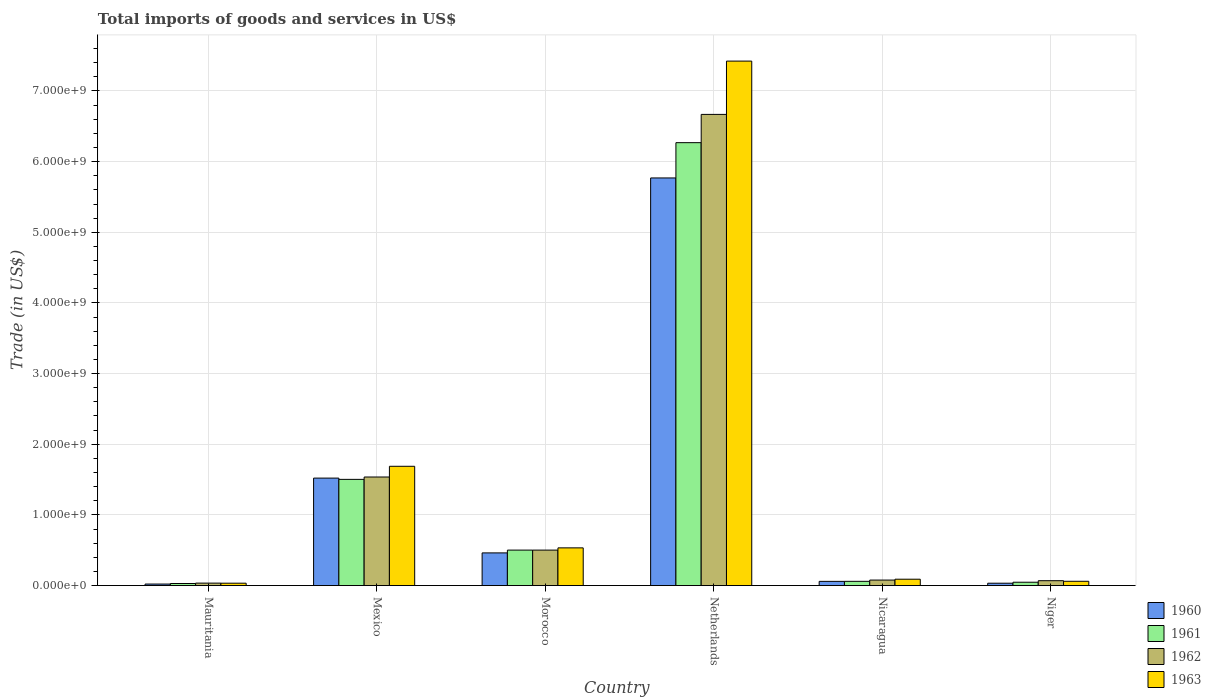Are the number of bars per tick equal to the number of legend labels?
Your response must be concise. Yes. How many bars are there on the 6th tick from the left?
Offer a terse response. 4. How many bars are there on the 2nd tick from the right?
Provide a short and direct response. 4. What is the label of the 5th group of bars from the left?
Provide a short and direct response. Nicaragua. In how many cases, is the number of bars for a given country not equal to the number of legend labels?
Make the answer very short. 0. What is the total imports of goods and services in 1962 in Morocco?
Your answer should be very brief. 5.02e+08. Across all countries, what is the maximum total imports of goods and services in 1962?
Provide a short and direct response. 6.67e+09. Across all countries, what is the minimum total imports of goods and services in 1960?
Offer a terse response. 2.13e+07. In which country was the total imports of goods and services in 1961 minimum?
Your answer should be very brief. Mauritania. What is the total total imports of goods and services in 1961 in the graph?
Make the answer very short. 8.41e+09. What is the difference between the total imports of goods and services in 1961 in Mexico and that in Netherlands?
Keep it short and to the point. -4.77e+09. What is the difference between the total imports of goods and services in 1961 in Mauritania and the total imports of goods and services in 1962 in Mexico?
Offer a very short reply. -1.51e+09. What is the average total imports of goods and services in 1960 per country?
Ensure brevity in your answer.  1.31e+09. What is the difference between the total imports of goods and services of/in 1961 and total imports of goods and services of/in 1960 in Morocco?
Your response must be concise. 3.95e+07. What is the ratio of the total imports of goods and services in 1963 in Morocco to that in Netherlands?
Give a very brief answer. 0.07. What is the difference between the highest and the second highest total imports of goods and services in 1960?
Offer a very short reply. 4.25e+09. What is the difference between the highest and the lowest total imports of goods and services in 1960?
Your answer should be compact. 5.75e+09. Is the sum of the total imports of goods and services in 1963 in Mauritania and Mexico greater than the maximum total imports of goods and services in 1961 across all countries?
Provide a succinct answer. No. Is it the case that in every country, the sum of the total imports of goods and services in 1963 and total imports of goods and services in 1961 is greater than the sum of total imports of goods and services in 1960 and total imports of goods and services in 1962?
Keep it short and to the point. No. How many countries are there in the graph?
Make the answer very short. 6. What is the title of the graph?
Offer a terse response. Total imports of goods and services in US$. Does "2003" appear as one of the legend labels in the graph?
Ensure brevity in your answer.  No. What is the label or title of the Y-axis?
Offer a terse response. Trade (in US$). What is the Trade (in US$) of 1960 in Mauritania?
Offer a terse response. 2.13e+07. What is the Trade (in US$) in 1961 in Mauritania?
Your answer should be very brief. 2.91e+07. What is the Trade (in US$) in 1962 in Mauritania?
Your answer should be very brief. 3.46e+07. What is the Trade (in US$) in 1963 in Mauritania?
Give a very brief answer. 3.36e+07. What is the Trade (in US$) in 1960 in Mexico?
Your response must be concise. 1.52e+09. What is the Trade (in US$) in 1961 in Mexico?
Ensure brevity in your answer.  1.50e+09. What is the Trade (in US$) in 1962 in Mexico?
Your answer should be compact. 1.54e+09. What is the Trade (in US$) in 1963 in Mexico?
Give a very brief answer. 1.69e+09. What is the Trade (in US$) of 1960 in Morocco?
Offer a very short reply. 4.62e+08. What is the Trade (in US$) of 1961 in Morocco?
Make the answer very short. 5.02e+08. What is the Trade (in US$) in 1962 in Morocco?
Your answer should be compact. 5.02e+08. What is the Trade (in US$) of 1963 in Morocco?
Make the answer very short. 5.34e+08. What is the Trade (in US$) of 1960 in Netherlands?
Provide a succinct answer. 5.77e+09. What is the Trade (in US$) in 1961 in Netherlands?
Your answer should be very brief. 6.27e+09. What is the Trade (in US$) in 1962 in Netherlands?
Offer a terse response. 6.67e+09. What is the Trade (in US$) in 1963 in Netherlands?
Provide a succinct answer. 7.42e+09. What is the Trade (in US$) of 1960 in Nicaragua?
Keep it short and to the point. 5.95e+07. What is the Trade (in US$) in 1961 in Nicaragua?
Provide a succinct answer. 5.99e+07. What is the Trade (in US$) in 1962 in Nicaragua?
Make the answer very short. 7.78e+07. What is the Trade (in US$) in 1963 in Nicaragua?
Ensure brevity in your answer.  8.99e+07. What is the Trade (in US$) in 1960 in Niger?
Provide a succinct answer. 3.33e+07. What is the Trade (in US$) in 1961 in Niger?
Your answer should be very brief. 4.71e+07. What is the Trade (in US$) in 1962 in Niger?
Offer a very short reply. 6.88e+07. What is the Trade (in US$) of 1963 in Niger?
Your response must be concise. 6.05e+07. Across all countries, what is the maximum Trade (in US$) of 1960?
Your answer should be compact. 5.77e+09. Across all countries, what is the maximum Trade (in US$) of 1961?
Ensure brevity in your answer.  6.27e+09. Across all countries, what is the maximum Trade (in US$) in 1962?
Provide a succinct answer. 6.67e+09. Across all countries, what is the maximum Trade (in US$) of 1963?
Offer a very short reply. 7.42e+09. Across all countries, what is the minimum Trade (in US$) in 1960?
Provide a succinct answer. 2.13e+07. Across all countries, what is the minimum Trade (in US$) in 1961?
Keep it short and to the point. 2.91e+07. Across all countries, what is the minimum Trade (in US$) in 1962?
Keep it short and to the point. 3.46e+07. Across all countries, what is the minimum Trade (in US$) of 1963?
Offer a very short reply. 3.36e+07. What is the total Trade (in US$) of 1960 in the graph?
Ensure brevity in your answer.  7.87e+09. What is the total Trade (in US$) of 1961 in the graph?
Your answer should be compact. 8.41e+09. What is the total Trade (in US$) in 1962 in the graph?
Your response must be concise. 8.89e+09. What is the total Trade (in US$) in 1963 in the graph?
Provide a succinct answer. 9.83e+09. What is the difference between the Trade (in US$) of 1960 in Mauritania and that in Mexico?
Make the answer very short. -1.50e+09. What is the difference between the Trade (in US$) in 1961 in Mauritania and that in Mexico?
Give a very brief answer. -1.47e+09. What is the difference between the Trade (in US$) of 1962 in Mauritania and that in Mexico?
Give a very brief answer. -1.50e+09. What is the difference between the Trade (in US$) in 1963 in Mauritania and that in Mexico?
Keep it short and to the point. -1.65e+09. What is the difference between the Trade (in US$) of 1960 in Mauritania and that in Morocco?
Make the answer very short. -4.41e+08. What is the difference between the Trade (in US$) in 1961 in Mauritania and that in Morocco?
Your answer should be very brief. -4.73e+08. What is the difference between the Trade (in US$) of 1962 in Mauritania and that in Morocco?
Ensure brevity in your answer.  -4.67e+08. What is the difference between the Trade (in US$) of 1963 in Mauritania and that in Morocco?
Provide a short and direct response. -5.00e+08. What is the difference between the Trade (in US$) of 1960 in Mauritania and that in Netherlands?
Offer a terse response. -5.75e+09. What is the difference between the Trade (in US$) in 1961 in Mauritania and that in Netherlands?
Provide a short and direct response. -6.24e+09. What is the difference between the Trade (in US$) of 1962 in Mauritania and that in Netherlands?
Provide a succinct answer. -6.63e+09. What is the difference between the Trade (in US$) in 1963 in Mauritania and that in Netherlands?
Offer a very short reply. -7.39e+09. What is the difference between the Trade (in US$) in 1960 in Mauritania and that in Nicaragua?
Give a very brief answer. -3.82e+07. What is the difference between the Trade (in US$) in 1961 in Mauritania and that in Nicaragua?
Provide a short and direct response. -3.08e+07. What is the difference between the Trade (in US$) of 1962 in Mauritania and that in Nicaragua?
Your answer should be compact. -4.33e+07. What is the difference between the Trade (in US$) in 1963 in Mauritania and that in Nicaragua?
Your answer should be very brief. -5.63e+07. What is the difference between the Trade (in US$) of 1960 in Mauritania and that in Niger?
Offer a very short reply. -1.20e+07. What is the difference between the Trade (in US$) in 1961 in Mauritania and that in Niger?
Your answer should be very brief. -1.80e+07. What is the difference between the Trade (in US$) in 1962 in Mauritania and that in Niger?
Give a very brief answer. -3.43e+07. What is the difference between the Trade (in US$) in 1963 in Mauritania and that in Niger?
Keep it short and to the point. -2.69e+07. What is the difference between the Trade (in US$) in 1960 in Mexico and that in Morocco?
Make the answer very short. 1.06e+09. What is the difference between the Trade (in US$) of 1961 in Mexico and that in Morocco?
Offer a terse response. 1.00e+09. What is the difference between the Trade (in US$) in 1962 in Mexico and that in Morocco?
Ensure brevity in your answer.  1.03e+09. What is the difference between the Trade (in US$) of 1963 in Mexico and that in Morocco?
Make the answer very short. 1.15e+09. What is the difference between the Trade (in US$) in 1960 in Mexico and that in Netherlands?
Ensure brevity in your answer.  -4.25e+09. What is the difference between the Trade (in US$) of 1961 in Mexico and that in Netherlands?
Keep it short and to the point. -4.77e+09. What is the difference between the Trade (in US$) in 1962 in Mexico and that in Netherlands?
Your answer should be compact. -5.13e+09. What is the difference between the Trade (in US$) of 1963 in Mexico and that in Netherlands?
Give a very brief answer. -5.74e+09. What is the difference between the Trade (in US$) in 1960 in Mexico and that in Nicaragua?
Keep it short and to the point. 1.46e+09. What is the difference between the Trade (in US$) of 1961 in Mexico and that in Nicaragua?
Give a very brief answer. 1.44e+09. What is the difference between the Trade (in US$) of 1962 in Mexico and that in Nicaragua?
Offer a very short reply. 1.46e+09. What is the difference between the Trade (in US$) of 1963 in Mexico and that in Nicaragua?
Your response must be concise. 1.60e+09. What is the difference between the Trade (in US$) in 1960 in Mexico and that in Niger?
Ensure brevity in your answer.  1.49e+09. What is the difference between the Trade (in US$) in 1961 in Mexico and that in Niger?
Your response must be concise. 1.46e+09. What is the difference between the Trade (in US$) in 1962 in Mexico and that in Niger?
Offer a very short reply. 1.47e+09. What is the difference between the Trade (in US$) of 1963 in Mexico and that in Niger?
Ensure brevity in your answer.  1.63e+09. What is the difference between the Trade (in US$) of 1960 in Morocco and that in Netherlands?
Offer a very short reply. -5.31e+09. What is the difference between the Trade (in US$) in 1961 in Morocco and that in Netherlands?
Provide a short and direct response. -5.77e+09. What is the difference between the Trade (in US$) of 1962 in Morocco and that in Netherlands?
Your answer should be very brief. -6.17e+09. What is the difference between the Trade (in US$) of 1963 in Morocco and that in Netherlands?
Offer a very short reply. -6.89e+09. What is the difference between the Trade (in US$) of 1960 in Morocco and that in Nicaragua?
Ensure brevity in your answer.  4.03e+08. What is the difference between the Trade (in US$) of 1961 in Morocco and that in Nicaragua?
Your answer should be very brief. 4.42e+08. What is the difference between the Trade (in US$) of 1962 in Morocco and that in Nicaragua?
Provide a succinct answer. 4.24e+08. What is the difference between the Trade (in US$) of 1963 in Morocco and that in Nicaragua?
Offer a very short reply. 4.44e+08. What is the difference between the Trade (in US$) in 1960 in Morocco and that in Niger?
Your response must be concise. 4.29e+08. What is the difference between the Trade (in US$) of 1961 in Morocco and that in Niger?
Offer a very short reply. 4.55e+08. What is the difference between the Trade (in US$) of 1962 in Morocco and that in Niger?
Provide a succinct answer. 4.33e+08. What is the difference between the Trade (in US$) in 1963 in Morocco and that in Niger?
Give a very brief answer. 4.73e+08. What is the difference between the Trade (in US$) of 1960 in Netherlands and that in Nicaragua?
Offer a very short reply. 5.71e+09. What is the difference between the Trade (in US$) in 1961 in Netherlands and that in Nicaragua?
Offer a very short reply. 6.21e+09. What is the difference between the Trade (in US$) of 1962 in Netherlands and that in Nicaragua?
Give a very brief answer. 6.59e+09. What is the difference between the Trade (in US$) in 1963 in Netherlands and that in Nicaragua?
Provide a short and direct response. 7.33e+09. What is the difference between the Trade (in US$) of 1960 in Netherlands and that in Niger?
Offer a very short reply. 5.74e+09. What is the difference between the Trade (in US$) of 1961 in Netherlands and that in Niger?
Offer a terse response. 6.22e+09. What is the difference between the Trade (in US$) of 1962 in Netherlands and that in Niger?
Keep it short and to the point. 6.60e+09. What is the difference between the Trade (in US$) of 1963 in Netherlands and that in Niger?
Your answer should be very brief. 7.36e+09. What is the difference between the Trade (in US$) of 1960 in Nicaragua and that in Niger?
Offer a very short reply. 2.62e+07. What is the difference between the Trade (in US$) in 1961 in Nicaragua and that in Niger?
Give a very brief answer. 1.28e+07. What is the difference between the Trade (in US$) of 1962 in Nicaragua and that in Niger?
Provide a short and direct response. 8.98e+06. What is the difference between the Trade (in US$) of 1963 in Nicaragua and that in Niger?
Provide a short and direct response. 2.94e+07. What is the difference between the Trade (in US$) of 1960 in Mauritania and the Trade (in US$) of 1961 in Mexico?
Provide a succinct answer. -1.48e+09. What is the difference between the Trade (in US$) of 1960 in Mauritania and the Trade (in US$) of 1962 in Mexico?
Your response must be concise. -1.52e+09. What is the difference between the Trade (in US$) of 1960 in Mauritania and the Trade (in US$) of 1963 in Mexico?
Provide a succinct answer. -1.67e+09. What is the difference between the Trade (in US$) in 1961 in Mauritania and the Trade (in US$) in 1962 in Mexico?
Your answer should be very brief. -1.51e+09. What is the difference between the Trade (in US$) of 1961 in Mauritania and the Trade (in US$) of 1963 in Mexico?
Provide a succinct answer. -1.66e+09. What is the difference between the Trade (in US$) of 1962 in Mauritania and the Trade (in US$) of 1963 in Mexico?
Offer a very short reply. -1.65e+09. What is the difference between the Trade (in US$) of 1960 in Mauritania and the Trade (in US$) of 1961 in Morocco?
Keep it short and to the point. -4.81e+08. What is the difference between the Trade (in US$) in 1960 in Mauritania and the Trade (in US$) in 1962 in Morocco?
Keep it short and to the point. -4.81e+08. What is the difference between the Trade (in US$) of 1960 in Mauritania and the Trade (in US$) of 1963 in Morocco?
Your answer should be compact. -5.12e+08. What is the difference between the Trade (in US$) of 1961 in Mauritania and the Trade (in US$) of 1962 in Morocco?
Your answer should be very brief. -4.73e+08. What is the difference between the Trade (in US$) in 1961 in Mauritania and the Trade (in US$) in 1963 in Morocco?
Provide a succinct answer. -5.04e+08. What is the difference between the Trade (in US$) in 1962 in Mauritania and the Trade (in US$) in 1963 in Morocco?
Make the answer very short. -4.99e+08. What is the difference between the Trade (in US$) in 1960 in Mauritania and the Trade (in US$) in 1961 in Netherlands?
Keep it short and to the point. -6.25e+09. What is the difference between the Trade (in US$) in 1960 in Mauritania and the Trade (in US$) in 1962 in Netherlands?
Provide a succinct answer. -6.65e+09. What is the difference between the Trade (in US$) in 1960 in Mauritania and the Trade (in US$) in 1963 in Netherlands?
Offer a terse response. -7.40e+09. What is the difference between the Trade (in US$) in 1961 in Mauritania and the Trade (in US$) in 1962 in Netherlands?
Offer a terse response. -6.64e+09. What is the difference between the Trade (in US$) of 1961 in Mauritania and the Trade (in US$) of 1963 in Netherlands?
Provide a short and direct response. -7.39e+09. What is the difference between the Trade (in US$) of 1962 in Mauritania and the Trade (in US$) of 1963 in Netherlands?
Offer a very short reply. -7.39e+09. What is the difference between the Trade (in US$) in 1960 in Mauritania and the Trade (in US$) in 1961 in Nicaragua?
Offer a terse response. -3.87e+07. What is the difference between the Trade (in US$) of 1960 in Mauritania and the Trade (in US$) of 1962 in Nicaragua?
Your answer should be very brief. -5.65e+07. What is the difference between the Trade (in US$) in 1960 in Mauritania and the Trade (in US$) in 1963 in Nicaragua?
Ensure brevity in your answer.  -6.86e+07. What is the difference between the Trade (in US$) in 1961 in Mauritania and the Trade (in US$) in 1962 in Nicaragua?
Offer a very short reply. -4.87e+07. What is the difference between the Trade (in US$) in 1961 in Mauritania and the Trade (in US$) in 1963 in Nicaragua?
Provide a succinct answer. -6.08e+07. What is the difference between the Trade (in US$) in 1962 in Mauritania and the Trade (in US$) in 1963 in Nicaragua?
Offer a terse response. -5.54e+07. What is the difference between the Trade (in US$) of 1960 in Mauritania and the Trade (in US$) of 1961 in Niger?
Provide a short and direct response. -2.59e+07. What is the difference between the Trade (in US$) of 1960 in Mauritania and the Trade (in US$) of 1962 in Niger?
Offer a very short reply. -4.76e+07. What is the difference between the Trade (in US$) of 1960 in Mauritania and the Trade (in US$) of 1963 in Niger?
Your response must be concise. -3.92e+07. What is the difference between the Trade (in US$) in 1961 in Mauritania and the Trade (in US$) in 1962 in Niger?
Provide a succinct answer. -3.97e+07. What is the difference between the Trade (in US$) of 1961 in Mauritania and the Trade (in US$) of 1963 in Niger?
Your answer should be very brief. -3.14e+07. What is the difference between the Trade (in US$) of 1962 in Mauritania and the Trade (in US$) of 1963 in Niger?
Offer a terse response. -2.60e+07. What is the difference between the Trade (in US$) of 1960 in Mexico and the Trade (in US$) of 1961 in Morocco?
Offer a terse response. 1.02e+09. What is the difference between the Trade (in US$) of 1960 in Mexico and the Trade (in US$) of 1962 in Morocco?
Provide a succinct answer. 1.02e+09. What is the difference between the Trade (in US$) in 1960 in Mexico and the Trade (in US$) in 1963 in Morocco?
Ensure brevity in your answer.  9.87e+08. What is the difference between the Trade (in US$) in 1961 in Mexico and the Trade (in US$) in 1962 in Morocco?
Your answer should be compact. 1.00e+09. What is the difference between the Trade (in US$) of 1961 in Mexico and the Trade (in US$) of 1963 in Morocco?
Ensure brevity in your answer.  9.70e+08. What is the difference between the Trade (in US$) of 1962 in Mexico and the Trade (in US$) of 1963 in Morocco?
Offer a very short reply. 1.00e+09. What is the difference between the Trade (in US$) of 1960 in Mexico and the Trade (in US$) of 1961 in Netherlands?
Provide a succinct answer. -4.75e+09. What is the difference between the Trade (in US$) in 1960 in Mexico and the Trade (in US$) in 1962 in Netherlands?
Ensure brevity in your answer.  -5.15e+09. What is the difference between the Trade (in US$) of 1960 in Mexico and the Trade (in US$) of 1963 in Netherlands?
Your answer should be very brief. -5.90e+09. What is the difference between the Trade (in US$) of 1961 in Mexico and the Trade (in US$) of 1962 in Netherlands?
Keep it short and to the point. -5.17e+09. What is the difference between the Trade (in US$) of 1961 in Mexico and the Trade (in US$) of 1963 in Netherlands?
Make the answer very short. -5.92e+09. What is the difference between the Trade (in US$) of 1962 in Mexico and the Trade (in US$) of 1963 in Netherlands?
Ensure brevity in your answer.  -5.89e+09. What is the difference between the Trade (in US$) of 1960 in Mexico and the Trade (in US$) of 1961 in Nicaragua?
Offer a terse response. 1.46e+09. What is the difference between the Trade (in US$) of 1960 in Mexico and the Trade (in US$) of 1962 in Nicaragua?
Keep it short and to the point. 1.44e+09. What is the difference between the Trade (in US$) of 1960 in Mexico and the Trade (in US$) of 1963 in Nicaragua?
Offer a terse response. 1.43e+09. What is the difference between the Trade (in US$) of 1961 in Mexico and the Trade (in US$) of 1962 in Nicaragua?
Your answer should be compact. 1.43e+09. What is the difference between the Trade (in US$) of 1961 in Mexico and the Trade (in US$) of 1963 in Nicaragua?
Your answer should be compact. 1.41e+09. What is the difference between the Trade (in US$) in 1962 in Mexico and the Trade (in US$) in 1963 in Nicaragua?
Offer a terse response. 1.45e+09. What is the difference between the Trade (in US$) of 1960 in Mexico and the Trade (in US$) of 1961 in Niger?
Your answer should be very brief. 1.47e+09. What is the difference between the Trade (in US$) of 1960 in Mexico and the Trade (in US$) of 1962 in Niger?
Make the answer very short. 1.45e+09. What is the difference between the Trade (in US$) of 1960 in Mexico and the Trade (in US$) of 1963 in Niger?
Give a very brief answer. 1.46e+09. What is the difference between the Trade (in US$) in 1961 in Mexico and the Trade (in US$) in 1962 in Niger?
Your answer should be compact. 1.43e+09. What is the difference between the Trade (in US$) of 1961 in Mexico and the Trade (in US$) of 1963 in Niger?
Offer a terse response. 1.44e+09. What is the difference between the Trade (in US$) of 1962 in Mexico and the Trade (in US$) of 1963 in Niger?
Provide a succinct answer. 1.48e+09. What is the difference between the Trade (in US$) in 1960 in Morocco and the Trade (in US$) in 1961 in Netherlands?
Your answer should be very brief. -5.81e+09. What is the difference between the Trade (in US$) in 1960 in Morocco and the Trade (in US$) in 1962 in Netherlands?
Keep it short and to the point. -6.21e+09. What is the difference between the Trade (in US$) in 1960 in Morocco and the Trade (in US$) in 1963 in Netherlands?
Give a very brief answer. -6.96e+09. What is the difference between the Trade (in US$) of 1961 in Morocco and the Trade (in US$) of 1962 in Netherlands?
Offer a terse response. -6.17e+09. What is the difference between the Trade (in US$) in 1961 in Morocco and the Trade (in US$) in 1963 in Netherlands?
Provide a short and direct response. -6.92e+09. What is the difference between the Trade (in US$) of 1962 in Morocco and the Trade (in US$) of 1963 in Netherlands?
Your answer should be compact. -6.92e+09. What is the difference between the Trade (in US$) in 1960 in Morocco and the Trade (in US$) in 1961 in Nicaragua?
Offer a terse response. 4.02e+08. What is the difference between the Trade (in US$) of 1960 in Morocco and the Trade (in US$) of 1962 in Nicaragua?
Keep it short and to the point. 3.85e+08. What is the difference between the Trade (in US$) in 1960 in Morocco and the Trade (in US$) in 1963 in Nicaragua?
Give a very brief answer. 3.72e+08. What is the difference between the Trade (in US$) of 1961 in Morocco and the Trade (in US$) of 1962 in Nicaragua?
Provide a short and direct response. 4.24e+08. What is the difference between the Trade (in US$) of 1961 in Morocco and the Trade (in US$) of 1963 in Nicaragua?
Give a very brief answer. 4.12e+08. What is the difference between the Trade (in US$) in 1962 in Morocco and the Trade (in US$) in 1963 in Nicaragua?
Give a very brief answer. 4.12e+08. What is the difference between the Trade (in US$) in 1960 in Morocco and the Trade (in US$) in 1961 in Niger?
Provide a short and direct response. 4.15e+08. What is the difference between the Trade (in US$) in 1960 in Morocco and the Trade (in US$) in 1962 in Niger?
Your answer should be compact. 3.94e+08. What is the difference between the Trade (in US$) of 1960 in Morocco and the Trade (in US$) of 1963 in Niger?
Your response must be concise. 4.02e+08. What is the difference between the Trade (in US$) of 1961 in Morocco and the Trade (in US$) of 1962 in Niger?
Provide a succinct answer. 4.33e+08. What is the difference between the Trade (in US$) in 1961 in Morocco and the Trade (in US$) in 1963 in Niger?
Provide a short and direct response. 4.41e+08. What is the difference between the Trade (in US$) of 1962 in Morocco and the Trade (in US$) of 1963 in Niger?
Your answer should be compact. 4.41e+08. What is the difference between the Trade (in US$) in 1960 in Netherlands and the Trade (in US$) in 1961 in Nicaragua?
Your answer should be compact. 5.71e+09. What is the difference between the Trade (in US$) in 1960 in Netherlands and the Trade (in US$) in 1962 in Nicaragua?
Keep it short and to the point. 5.69e+09. What is the difference between the Trade (in US$) of 1960 in Netherlands and the Trade (in US$) of 1963 in Nicaragua?
Provide a succinct answer. 5.68e+09. What is the difference between the Trade (in US$) of 1961 in Netherlands and the Trade (in US$) of 1962 in Nicaragua?
Offer a very short reply. 6.19e+09. What is the difference between the Trade (in US$) of 1961 in Netherlands and the Trade (in US$) of 1963 in Nicaragua?
Provide a succinct answer. 6.18e+09. What is the difference between the Trade (in US$) in 1962 in Netherlands and the Trade (in US$) in 1963 in Nicaragua?
Offer a terse response. 6.58e+09. What is the difference between the Trade (in US$) of 1960 in Netherlands and the Trade (in US$) of 1961 in Niger?
Your answer should be compact. 5.72e+09. What is the difference between the Trade (in US$) of 1960 in Netherlands and the Trade (in US$) of 1962 in Niger?
Ensure brevity in your answer.  5.70e+09. What is the difference between the Trade (in US$) of 1960 in Netherlands and the Trade (in US$) of 1963 in Niger?
Your response must be concise. 5.71e+09. What is the difference between the Trade (in US$) in 1961 in Netherlands and the Trade (in US$) in 1962 in Niger?
Make the answer very short. 6.20e+09. What is the difference between the Trade (in US$) of 1961 in Netherlands and the Trade (in US$) of 1963 in Niger?
Ensure brevity in your answer.  6.21e+09. What is the difference between the Trade (in US$) of 1962 in Netherlands and the Trade (in US$) of 1963 in Niger?
Provide a succinct answer. 6.61e+09. What is the difference between the Trade (in US$) in 1960 in Nicaragua and the Trade (in US$) in 1961 in Niger?
Ensure brevity in your answer.  1.23e+07. What is the difference between the Trade (in US$) of 1960 in Nicaragua and the Trade (in US$) of 1962 in Niger?
Offer a very short reply. -9.39e+06. What is the difference between the Trade (in US$) in 1960 in Nicaragua and the Trade (in US$) in 1963 in Niger?
Offer a very short reply. -1.06e+06. What is the difference between the Trade (in US$) in 1961 in Nicaragua and the Trade (in US$) in 1962 in Niger?
Ensure brevity in your answer.  -8.90e+06. What is the difference between the Trade (in US$) of 1961 in Nicaragua and the Trade (in US$) of 1963 in Niger?
Ensure brevity in your answer.  -5.73e+05. What is the difference between the Trade (in US$) of 1962 in Nicaragua and the Trade (in US$) of 1963 in Niger?
Ensure brevity in your answer.  1.73e+07. What is the average Trade (in US$) of 1960 per country?
Offer a terse response. 1.31e+09. What is the average Trade (in US$) of 1961 per country?
Your answer should be compact. 1.40e+09. What is the average Trade (in US$) in 1962 per country?
Make the answer very short. 1.48e+09. What is the average Trade (in US$) in 1963 per country?
Keep it short and to the point. 1.64e+09. What is the difference between the Trade (in US$) in 1960 and Trade (in US$) in 1961 in Mauritania?
Offer a very short reply. -7.84e+06. What is the difference between the Trade (in US$) of 1960 and Trade (in US$) of 1962 in Mauritania?
Your answer should be very brief. -1.33e+07. What is the difference between the Trade (in US$) of 1960 and Trade (in US$) of 1963 in Mauritania?
Offer a terse response. -1.23e+07. What is the difference between the Trade (in US$) in 1961 and Trade (in US$) in 1962 in Mauritania?
Your answer should be very brief. -5.42e+06. What is the difference between the Trade (in US$) in 1961 and Trade (in US$) in 1963 in Mauritania?
Your response must be concise. -4.48e+06. What is the difference between the Trade (in US$) in 1962 and Trade (in US$) in 1963 in Mauritania?
Your answer should be compact. 9.34e+05. What is the difference between the Trade (in US$) of 1960 and Trade (in US$) of 1961 in Mexico?
Give a very brief answer. 1.78e+07. What is the difference between the Trade (in US$) in 1960 and Trade (in US$) in 1962 in Mexico?
Provide a short and direct response. -1.56e+07. What is the difference between the Trade (in US$) of 1960 and Trade (in US$) of 1963 in Mexico?
Provide a succinct answer. -1.67e+08. What is the difference between the Trade (in US$) in 1961 and Trade (in US$) in 1962 in Mexico?
Keep it short and to the point. -3.34e+07. What is the difference between the Trade (in US$) of 1961 and Trade (in US$) of 1963 in Mexico?
Ensure brevity in your answer.  -1.85e+08. What is the difference between the Trade (in US$) of 1962 and Trade (in US$) of 1963 in Mexico?
Provide a short and direct response. -1.52e+08. What is the difference between the Trade (in US$) of 1960 and Trade (in US$) of 1961 in Morocco?
Provide a short and direct response. -3.95e+07. What is the difference between the Trade (in US$) of 1960 and Trade (in US$) of 1962 in Morocco?
Your answer should be compact. -3.95e+07. What is the difference between the Trade (in US$) of 1960 and Trade (in US$) of 1963 in Morocco?
Your answer should be very brief. -7.11e+07. What is the difference between the Trade (in US$) of 1961 and Trade (in US$) of 1962 in Morocco?
Provide a short and direct response. 0. What is the difference between the Trade (in US$) of 1961 and Trade (in US$) of 1963 in Morocco?
Your answer should be compact. -3.16e+07. What is the difference between the Trade (in US$) of 1962 and Trade (in US$) of 1963 in Morocco?
Offer a terse response. -3.16e+07. What is the difference between the Trade (in US$) in 1960 and Trade (in US$) in 1961 in Netherlands?
Your response must be concise. -4.99e+08. What is the difference between the Trade (in US$) of 1960 and Trade (in US$) of 1962 in Netherlands?
Make the answer very short. -8.99e+08. What is the difference between the Trade (in US$) in 1960 and Trade (in US$) in 1963 in Netherlands?
Your response must be concise. -1.65e+09. What is the difference between the Trade (in US$) in 1961 and Trade (in US$) in 1962 in Netherlands?
Your answer should be compact. -4.00e+08. What is the difference between the Trade (in US$) of 1961 and Trade (in US$) of 1963 in Netherlands?
Give a very brief answer. -1.15e+09. What is the difference between the Trade (in US$) in 1962 and Trade (in US$) in 1963 in Netherlands?
Offer a terse response. -7.54e+08. What is the difference between the Trade (in US$) in 1960 and Trade (in US$) in 1961 in Nicaragua?
Offer a very short reply. -4.83e+05. What is the difference between the Trade (in US$) in 1960 and Trade (in US$) in 1962 in Nicaragua?
Offer a very short reply. -1.84e+07. What is the difference between the Trade (in US$) in 1960 and Trade (in US$) in 1963 in Nicaragua?
Your response must be concise. -3.05e+07. What is the difference between the Trade (in US$) of 1961 and Trade (in US$) of 1962 in Nicaragua?
Your answer should be compact. -1.79e+07. What is the difference between the Trade (in US$) in 1961 and Trade (in US$) in 1963 in Nicaragua?
Provide a short and direct response. -3.00e+07. What is the difference between the Trade (in US$) of 1962 and Trade (in US$) of 1963 in Nicaragua?
Provide a succinct answer. -1.21e+07. What is the difference between the Trade (in US$) in 1960 and Trade (in US$) in 1961 in Niger?
Provide a short and direct response. -1.39e+07. What is the difference between the Trade (in US$) of 1960 and Trade (in US$) of 1962 in Niger?
Your answer should be compact. -3.56e+07. What is the difference between the Trade (in US$) of 1960 and Trade (in US$) of 1963 in Niger?
Your answer should be compact. -2.72e+07. What is the difference between the Trade (in US$) in 1961 and Trade (in US$) in 1962 in Niger?
Give a very brief answer. -2.17e+07. What is the difference between the Trade (in US$) in 1961 and Trade (in US$) in 1963 in Niger?
Make the answer very short. -1.34e+07. What is the difference between the Trade (in US$) in 1962 and Trade (in US$) in 1963 in Niger?
Offer a terse response. 8.33e+06. What is the ratio of the Trade (in US$) in 1960 in Mauritania to that in Mexico?
Give a very brief answer. 0.01. What is the ratio of the Trade (in US$) in 1961 in Mauritania to that in Mexico?
Give a very brief answer. 0.02. What is the ratio of the Trade (in US$) of 1962 in Mauritania to that in Mexico?
Your answer should be compact. 0.02. What is the ratio of the Trade (in US$) in 1963 in Mauritania to that in Mexico?
Give a very brief answer. 0.02. What is the ratio of the Trade (in US$) in 1960 in Mauritania to that in Morocco?
Make the answer very short. 0.05. What is the ratio of the Trade (in US$) of 1961 in Mauritania to that in Morocco?
Provide a succinct answer. 0.06. What is the ratio of the Trade (in US$) in 1962 in Mauritania to that in Morocco?
Provide a succinct answer. 0.07. What is the ratio of the Trade (in US$) of 1963 in Mauritania to that in Morocco?
Give a very brief answer. 0.06. What is the ratio of the Trade (in US$) of 1960 in Mauritania to that in Netherlands?
Ensure brevity in your answer.  0. What is the ratio of the Trade (in US$) in 1961 in Mauritania to that in Netherlands?
Your response must be concise. 0. What is the ratio of the Trade (in US$) of 1962 in Mauritania to that in Netherlands?
Give a very brief answer. 0.01. What is the ratio of the Trade (in US$) of 1963 in Mauritania to that in Netherlands?
Offer a terse response. 0. What is the ratio of the Trade (in US$) in 1960 in Mauritania to that in Nicaragua?
Your answer should be very brief. 0.36. What is the ratio of the Trade (in US$) of 1961 in Mauritania to that in Nicaragua?
Offer a terse response. 0.49. What is the ratio of the Trade (in US$) in 1962 in Mauritania to that in Nicaragua?
Provide a short and direct response. 0.44. What is the ratio of the Trade (in US$) of 1963 in Mauritania to that in Nicaragua?
Your answer should be very brief. 0.37. What is the ratio of the Trade (in US$) in 1960 in Mauritania to that in Niger?
Offer a terse response. 0.64. What is the ratio of the Trade (in US$) of 1961 in Mauritania to that in Niger?
Offer a terse response. 0.62. What is the ratio of the Trade (in US$) of 1962 in Mauritania to that in Niger?
Your answer should be compact. 0.5. What is the ratio of the Trade (in US$) of 1963 in Mauritania to that in Niger?
Give a very brief answer. 0.56. What is the ratio of the Trade (in US$) of 1960 in Mexico to that in Morocco?
Make the answer very short. 3.29. What is the ratio of the Trade (in US$) in 1961 in Mexico to that in Morocco?
Provide a short and direct response. 2.99. What is the ratio of the Trade (in US$) of 1962 in Mexico to that in Morocco?
Provide a short and direct response. 3.06. What is the ratio of the Trade (in US$) in 1963 in Mexico to that in Morocco?
Offer a very short reply. 3.16. What is the ratio of the Trade (in US$) of 1960 in Mexico to that in Netherlands?
Make the answer very short. 0.26. What is the ratio of the Trade (in US$) of 1961 in Mexico to that in Netherlands?
Make the answer very short. 0.24. What is the ratio of the Trade (in US$) of 1962 in Mexico to that in Netherlands?
Provide a succinct answer. 0.23. What is the ratio of the Trade (in US$) of 1963 in Mexico to that in Netherlands?
Offer a terse response. 0.23. What is the ratio of the Trade (in US$) of 1960 in Mexico to that in Nicaragua?
Your answer should be very brief. 25.58. What is the ratio of the Trade (in US$) of 1961 in Mexico to that in Nicaragua?
Your answer should be very brief. 25.07. What is the ratio of the Trade (in US$) of 1962 in Mexico to that in Nicaragua?
Ensure brevity in your answer.  19.74. What is the ratio of the Trade (in US$) in 1963 in Mexico to that in Nicaragua?
Your response must be concise. 18.77. What is the ratio of the Trade (in US$) of 1960 in Mexico to that in Niger?
Your answer should be very brief. 45.69. What is the ratio of the Trade (in US$) of 1961 in Mexico to that in Niger?
Provide a succinct answer. 31.88. What is the ratio of the Trade (in US$) in 1962 in Mexico to that in Niger?
Make the answer very short. 22.32. What is the ratio of the Trade (in US$) in 1963 in Mexico to that in Niger?
Give a very brief answer. 27.89. What is the ratio of the Trade (in US$) in 1960 in Morocco to that in Netherlands?
Make the answer very short. 0.08. What is the ratio of the Trade (in US$) in 1961 in Morocco to that in Netherlands?
Offer a very short reply. 0.08. What is the ratio of the Trade (in US$) in 1962 in Morocco to that in Netherlands?
Make the answer very short. 0.08. What is the ratio of the Trade (in US$) of 1963 in Morocco to that in Netherlands?
Your answer should be compact. 0.07. What is the ratio of the Trade (in US$) of 1960 in Morocco to that in Nicaragua?
Provide a short and direct response. 7.78. What is the ratio of the Trade (in US$) in 1961 in Morocco to that in Nicaragua?
Provide a succinct answer. 8.37. What is the ratio of the Trade (in US$) in 1962 in Morocco to that in Nicaragua?
Offer a terse response. 6.45. What is the ratio of the Trade (in US$) of 1963 in Morocco to that in Nicaragua?
Your response must be concise. 5.93. What is the ratio of the Trade (in US$) of 1960 in Morocco to that in Niger?
Offer a terse response. 13.89. What is the ratio of the Trade (in US$) of 1961 in Morocco to that in Niger?
Provide a succinct answer. 10.65. What is the ratio of the Trade (in US$) of 1962 in Morocco to that in Niger?
Your answer should be compact. 7.29. What is the ratio of the Trade (in US$) in 1963 in Morocco to that in Niger?
Your response must be concise. 8.82. What is the ratio of the Trade (in US$) of 1960 in Netherlands to that in Nicaragua?
Keep it short and to the point. 97.02. What is the ratio of the Trade (in US$) of 1961 in Netherlands to that in Nicaragua?
Your answer should be very brief. 104.57. What is the ratio of the Trade (in US$) of 1962 in Netherlands to that in Nicaragua?
Offer a terse response. 85.68. What is the ratio of the Trade (in US$) of 1963 in Netherlands to that in Nicaragua?
Make the answer very short. 82.56. What is the ratio of the Trade (in US$) in 1960 in Netherlands to that in Niger?
Make the answer very short. 173.31. What is the ratio of the Trade (in US$) of 1961 in Netherlands to that in Niger?
Your answer should be very brief. 132.96. What is the ratio of the Trade (in US$) in 1962 in Netherlands to that in Niger?
Provide a succinct answer. 96.86. What is the ratio of the Trade (in US$) of 1963 in Netherlands to that in Niger?
Ensure brevity in your answer.  122.66. What is the ratio of the Trade (in US$) of 1960 in Nicaragua to that in Niger?
Keep it short and to the point. 1.79. What is the ratio of the Trade (in US$) in 1961 in Nicaragua to that in Niger?
Your answer should be very brief. 1.27. What is the ratio of the Trade (in US$) in 1962 in Nicaragua to that in Niger?
Your answer should be compact. 1.13. What is the ratio of the Trade (in US$) of 1963 in Nicaragua to that in Niger?
Keep it short and to the point. 1.49. What is the difference between the highest and the second highest Trade (in US$) in 1960?
Your answer should be very brief. 4.25e+09. What is the difference between the highest and the second highest Trade (in US$) of 1961?
Offer a terse response. 4.77e+09. What is the difference between the highest and the second highest Trade (in US$) in 1962?
Offer a terse response. 5.13e+09. What is the difference between the highest and the second highest Trade (in US$) in 1963?
Your answer should be very brief. 5.74e+09. What is the difference between the highest and the lowest Trade (in US$) of 1960?
Your answer should be compact. 5.75e+09. What is the difference between the highest and the lowest Trade (in US$) in 1961?
Offer a very short reply. 6.24e+09. What is the difference between the highest and the lowest Trade (in US$) in 1962?
Provide a short and direct response. 6.63e+09. What is the difference between the highest and the lowest Trade (in US$) of 1963?
Your answer should be compact. 7.39e+09. 